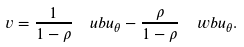<formula> <loc_0><loc_0><loc_500><loc_500>v = \frac { 1 } { 1 - \rho } \ \ u b { u } _ { \theta } - \frac { \rho } { 1 - \rho } \ \ w b { u } _ { \theta } .</formula> 